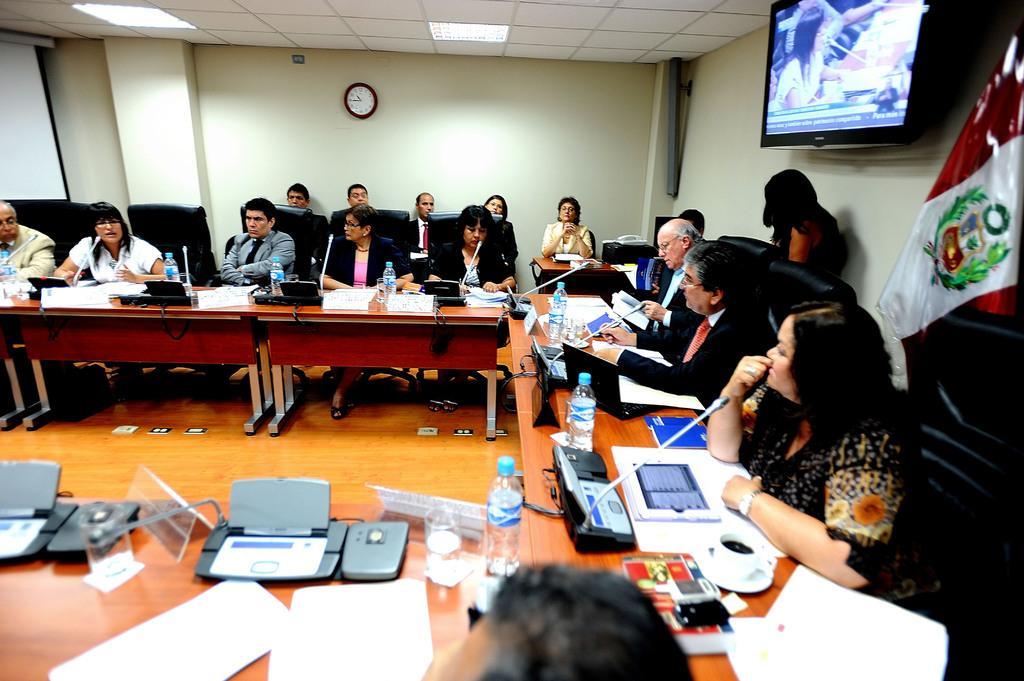Can you describe this image briefly? There are many people sitting on chairs. In front of them there are tables. On the tables there are bottles, mics, cup with saucer, name boards, few electronics devices and many other items. On the ceiling there are lights. In the back there is a wall with a clock. On the right side there is a wall with a television. Also there is a flag. 